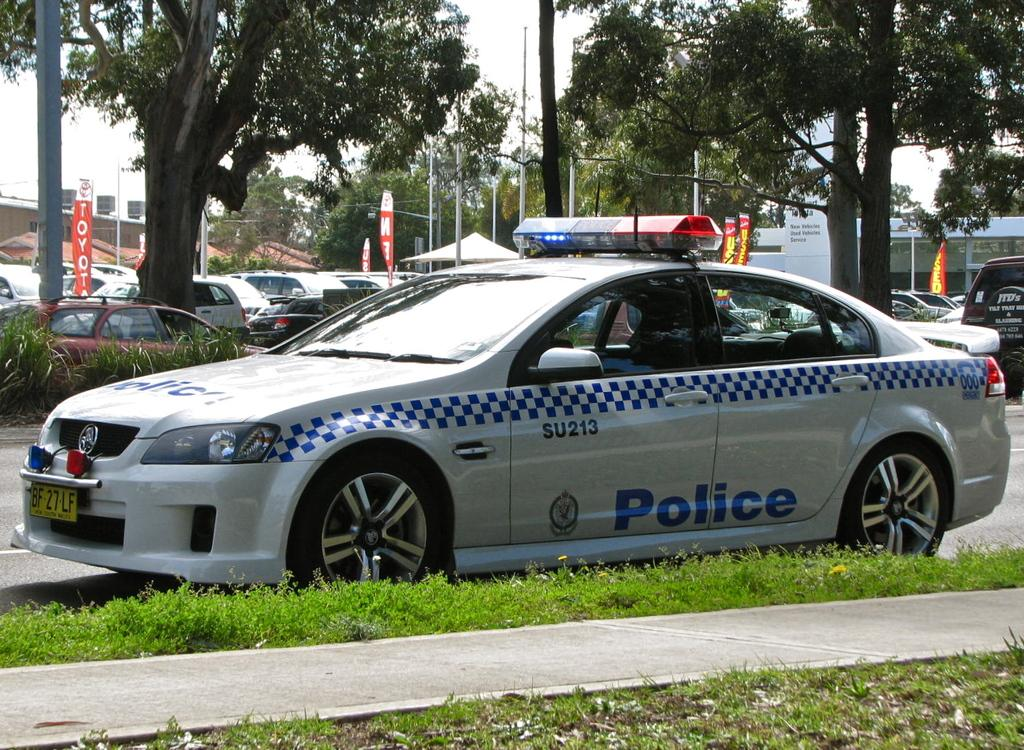What type of vegetation is at the bottom of the image? There is grass at the bottom of the image. What can be seen in the middle of the image? There are trees and cars in the middle of the image. What is visible in the background of the image? There is a sky visible in the background of the image. What type of jewel can be seen in the image? There is no jewel present in the image. How does the anger manifest in the image? There is no indication of anger in the image; it features grass, trees, cars, and a sky. 